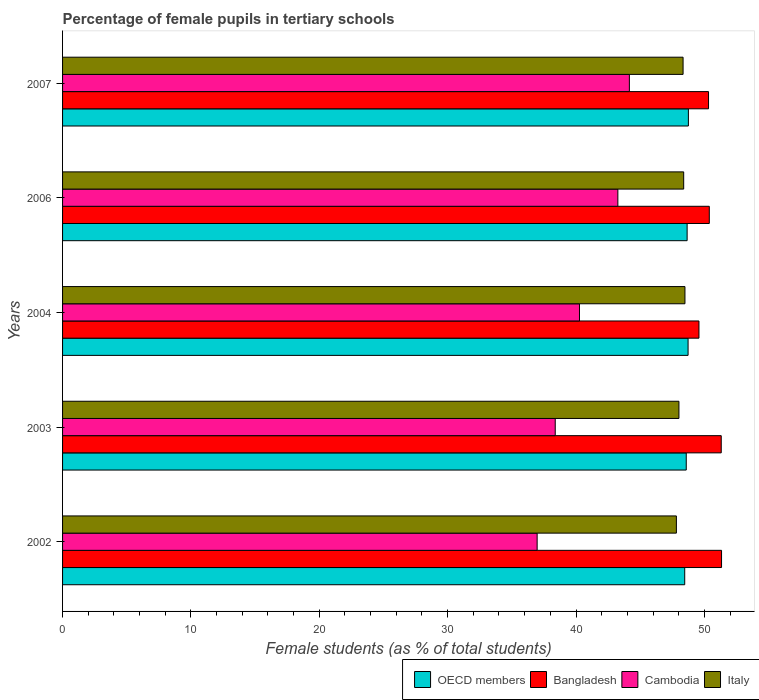How many groups of bars are there?
Your answer should be very brief. 5. Are the number of bars per tick equal to the number of legend labels?
Offer a terse response. Yes. Are the number of bars on each tick of the Y-axis equal?
Provide a short and direct response. Yes. How many bars are there on the 2nd tick from the bottom?
Give a very brief answer. 4. What is the label of the 3rd group of bars from the top?
Make the answer very short. 2004. What is the percentage of female pupils in tertiary schools in Italy in 2002?
Provide a short and direct response. 47.82. Across all years, what is the maximum percentage of female pupils in tertiary schools in Bangladesh?
Make the answer very short. 51.34. Across all years, what is the minimum percentage of female pupils in tertiary schools in Cambodia?
Give a very brief answer. 36.97. In which year was the percentage of female pupils in tertiary schools in Cambodia maximum?
Ensure brevity in your answer.  2007. In which year was the percentage of female pupils in tertiary schools in Cambodia minimum?
Your answer should be very brief. 2002. What is the total percentage of female pupils in tertiary schools in OECD members in the graph?
Offer a terse response. 243.2. What is the difference between the percentage of female pupils in tertiary schools in Italy in 2002 and that in 2007?
Offer a terse response. -0.52. What is the difference between the percentage of female pupils in tertiary schools in Italy in 2004 and the percentage of female pupils in tertiary schools in Bangladesh in 2003?
Ensure brevity in your answer.  -2.83. What is the average percentage of female pupils in tertiary schools in Bangladesh per year?
Offer a terse response. 50.59. In the year 2007, what is the difference between the percentage of female pupils in tertiary schools in Bangladesh and percentage of female pupils in tertiary schools in Italy?
Offer a terse response. 1.98. In how many years, is the percentage of female pupils in tertiary schools in OECD members greater than 34 %?
Your answer should be compact. 5. What is the ratio of the percentage of female pupils in tertiary schools in Italy in 2002 to that in 2007?
Provide a short and direct response. 0.99. What is the difference between the highest and the second highest percentage of female pupils in tertiary schools in Bangladesh?
Offer a very short reply. 0.02. What is the difference between the highest and the lowest percentage of female pupils in tertiary schools in OECD members?
Provide a succinct answer. 0.29. In how many years, is the percentage of female pupils in tertiary schools in Bangladesh greater than the average percentage of female pupils in tertiary schools in Bangladesh taken over all years?
Make the answer very short. 2. Is the sum of the percentage of female pupils in tertiary schools in Cambodia in 2006 and 2007 greater than the maximum percentage of female pupils in tertiary schools in Italy across all years?
Provide a short and direct response. Yes. What does the 3rd bar from the top in 2002 represents?
Provide a succinct answer. Bangladesh. Is it the case that in every year, the sum of the percentage of female pupils in tertiary schools in OECD members and percentage of female pupils in tertiary schools in Cambodia is greater than the percentage of female pupils in tertiary schools in Italy?
Make the answer very short. Yes. Does the graph contain any zero values?
Your answer should be compact. No. Does the graph contain grids?
Your answer should be very brief. No. How many legend labels are there?
Your response must be concise. 4. How are the legend labels stacked?
Your answer should be compact. Horizontal. What is the title of the graph?
Your response must be concise. Percentage of female pupils in tertiary schools. What is the label or title of the X-axis?
Your answer should be compact. Female students (as % of total students). What is the Female students (as % of total students) of OECD members in 2002?
Offer a terse response. 48.47. What is the Female students (as % of total students) in Bangladesh in 2002?
Offer a terse response. 51.34. What is the Female students (as % of total students) in Cambodia in 2002?
Provide a succinct answer. 36.97. What is the Female students (as % of total students) in Italy in 2002?
Keep it short and to the point. 47.82. What is the Female students (as % of total students) of OECD members in 2003?
Your answer should be very brief. 48.59. What is the Female students (as % of total students) of Bangladesh in 2003?
Your answer should be compact. 51.31. What is the Female students (as % of total students) in Cambodia in 2003?
Your answer should be compact. 38.38. What is the Female students (as % of total students) in Italy in 2003?
Your answer should be very brief. 48.02. What is the Female students (as % of total students) in OECD members in 2004?
Offer a terse response. 48.73. What is the Female students (as % of total students) in Bangladesh in 2004?
Offer a terse response. 49.58. What is the Female students (as % of total students) in Cambodia in 2004?
Offer a very short reply. 40.27. What is the Female students (as % of total students) of Italy in 2004?
Provide a succinct answer. 48.49. What is the Female students (as % of total students) of OECD members in 2006?
Keep it short and to the point. 48.66. What is the Female students (as % of total students) in Bangladesh in 2006?
Your answer should be very brief. 50.38. What is the Female students (as % of total students) in Cambodia in 2006?
Give a very brief answer. 43.26. What is the Female students (as % of total students) of Italy in 2006?
Your answer should be compact. 48.39. What is the Female students (as % of total students) of OECD members in 2007?
Your response must be concise. 48.76. What is the Female students (as % of total students) of Bangladesh in 2007?
Provide a succinct answer. 50.32. What is the Female students (as % of total students) of Cambodia in 2007?
Your response must be concise. 44.16. What is the Female students (as % of total students) of Italy in 2007?
Your answer should be compact. 48.34. Across all years, what is the maximum Female students (as % of total students) of OECD members?
Your response must be concise. 48.76. Across all years, what is the maximum Female students (as % of total students) of Bangladesh?
Your response must be concise. 51.34. Across all years, what is the maximum Female students (as % of total students) in Cambodia?
Offer a terse response. 44.16. Across all years, what is the maximum Female students (as % of total students) in Italy?
Your answer should be very brief. 48.49. Across all years, what is the minimum Female students (as % of total students) in OECD members?
Provide a short and direct response. 48.47. Across all years, what is the minimum Female students (as % of total students) in Bangladesh?
Make the answer very short. 49.58. Across all years, what is the minimum Female students (as % of total students) of Cambodia?
Your response must be concise. 36.97. Across all years, what is the minimum Female students (as % of total students) in Italy?
Give a very brief answer. 47.82. What is the total Female students (as % of total students) of OECD members in the graph?
Give a very brief answer. 243.2. What is the total Female students (as % of total students) in Bangladesh in the graph?
Make the answer very short. 252.94. What is the total Female students (as % of total students) of Cambodia in the graph?
Keep it short and to the point. 203.05. What is the total Female students (as % of total students) in Italy in the graph?
Offer a terse response. 241.06. What is the difference between the Female students (as % of total students) in OECD members in 2002 and that in 2003?
Your response must be concise. -0.12. What is the difference between the Female students (as % of total students) in Bangladesh in 2002 and that in 2003?
Your answer should be compact. 0.02. What is the difference between the Female students (as % of total students) in Cambodia in 2002 and that in 2003?
Offer a very short reply. -1.41. What is the difference between the Female students (as % of total students) of Italy in 2002 and that in 2003?
Provide a succinct answer. -0.2. What is the difference between the Female students (as % of total students) in OECD members in 2002 and that in 2004?
Your answer should be compact. -0.26. What is the difference between the Female students (as % of total students) in Bangladesh in 2002 and that in 2004?
Offer a terse response. 1.76. What is the difference between the Female students (as % of total students) in Cambodia in 2002 and that in 2004?
Keep it short and to the point. -3.3. What is the difference between the Female students (as % of total students) of Italy in 2002 and that in 2004?
Provide a short and direct response. -0.67. What is the difference between the Female students (as % of total students) of OECD members in 2002 and that in 2006?
Give a very brief answer. -0.19. What is the difference between the Female students (as % of total students) in Bangladesh in 2002 and that in 2006?
Offer a very short reply. 0.95. What is the difference between the Female students (as % of total students) of Cambodia in 2002 and that in 2006?
Ensure brevity in your answer.  -6.29. What is the difference between the Female students (as % of total students) in Italy in 2002 and that in 2006?
Provide a succinct answer. -0.57. What is the difference between the Female students (as % of total students) of OECD members in 2002 and that in 2007?
Offer a terse response. -0.29. What is the difference between the Female students (as % of total students) of Cambodia in 2002 and that in 2007?
Make the answer very short. -7.19. What is the difference between the Female students (as % of total students) in Italy in 2002 and that in 2007?
Your answer should be compact. -0.52. What is the difference between the Female students (as % of total students) of OECD members in 2003 and that in 2004?
Provide a succinct answer. -0.14. What is the difference between the Female students (as % of total students) in Bangladesh in 2003 and that in 2004?
Your response must be concise. 1.74. What is the difference between the Female students (as % of total students) in Cambodia in 2003 and that in 2004?
Your answer should be compact. -1.89. What is the difference between the Female students (as % of total students) of Italy in 2003 and that in 2004?
Provide a short and direct response. -0.47. What is the difference between the Female students (as % of total students) in OECD members in 2003 and that in 2006?
Make the answer very short. -0.07. What is the difference between the Female students (as % of total students) in Bangladesh in 2003 and that in 2006?
Your answer should be very brief. 0.93. What is the difference between the Female students (as % of total students) in Cambodia in 2003 and that in 2006?
Give a very brief answer. -4.88. What is the difference between the Female students (as % of total students) in Italy in 2003 and that in 2006?
Your answer should be compact. -0.37. What is the difference between the Female students (as % of total students) of OECD members in 2003 and that in 2007?
Give a very brief answer. -0.17. What is the difference between the Female students (as % of total students) in Cambodia in 2003 and that in 2007?
Your answer should be very brief. -5.78. What is the difference between the Female students (as % of total students) of Italy in 2003 and that in 2007?
Your answer should be very brief. -0.32. What is the difference between the Female students (as % of total students) in OECD members in 2004 and that in 2006?
Provide a succinct answer. 0.07. What is the difference between the Female students (as % of total students) in Bangladesh in 2004 and that in 2006?
Offer a very short reply. -0.81. What is the difference between the Female students (as % of total students) in Cambodia in 2004 and that in 2006?
Make the answer very short. -2.99. What is the difference between the Female students (as % of total students) in Italy in 2004 and that in 2006?
Keep it short and to the point. 0.1. What is the difference between the Female students (as % of total students) of OECD members in 2004 and that in 2007?
Make the answer very short. -0.02. What is the difference between the Female students (as % of total students) of Bangladesh in 2004 and that in 2007?
Your response must be concise. -0.75. What is the difference between the Female students (as % of total students) in Cambodia in 2004 and that in 2007?
Provide a succinct answer. -3.89. What is the difference between the Female students (as % of total students) of Italy in 2004 and that in 2007?
Your answer should be very brief. 0.15. What is the difference between the Female students (as % of total students) of OECD members in 2006 and that in 2007?
Provide a succinct answer. -0.1. What is the difference between the Female students (as % of total students) in Bangladesh in 2006 and that in 2007?
Your answer should be very brief. 0.06. What is the difference between the Female students (as % of total students) of Cambodia in 2006 and that in 2007?
Offer a terse response. -0.9. What is the difference between the Female students (as % of total students) in Italy in 2006 and that in 2007?
Provide a short and direct response. 0.05. What is the difference between the Female students (as % of total students) of OECD members in 2002 and the Female students (as % of total students) of Bangladesh in 2003?
Your answer should be compact. -2.85. What is the difference between the Female students (as % of total students) of OECD members in 2002 and the Female students (as % of total students) of Cambodia in 2003?
Your response must be concise. 10.09. What is the difference between the Female students (as % of total students) in OECD members in 2002 and the Female students (as % of total students) in Italy in 2003?
Your answer should be compact. 0.45. What is the difference between the Female students (as % of total students) in Bangladesh in 2002 and the Female students (as % of total students) in Cambodia in 2003?
Give a very brief answer. 12.96. What is the difference between the Female students (as % of total students) of Bangladesh in 2002 and the Female students (as % of total students) of Italy in 2003?
Keep it short and to the point. 3.32. What is the difference between the Female students (as % of total students) of Cambodia in 2002 and the Female students (as % of total students) of Italy in 2003?
Provide a short and direct response. -11.05. What is the difference between the Female students (as % of total students) in OECD members in 2002 and the Female students (as % of total students) in Bangladesh in 2004?
Offer a very short reply. -1.11. What is the difference between the Female students (as % of total students) of OECD members in 2002 and the Female students (as % of total students) of Cambodia in 2004?
Provide a short and direct response. 8.2. What is the difference between the Female students (as % of total students) of OECD members in 2002 and the Female students (as % of total students) of Italy in 2004?
Make the answer very short. -0.02. What is the difference between the Female students (as % of total students) in Bangladesh in 2002 and the Female students (as % of total students) in Cambodia in 2004?
Give a very brief answer. 11.07. What is the difference between the Female students (as % of total students) in Bangladesh in 2002 and the Female students (as % of total students) in Italy in 2004?
Keep it short and to the point. 2.85. What is the difference between the Female students (as % of total students) in Cambodia in 2002 and the Female students (as % of total students) in Italy in 2004?
Offer a very short reply. -11.52. What is the difference between the Female students (as % of total students) in OECD members in 2002 and the Female students (as % of total students) in Bangladesh in 2006?
Your answer should be very brief. -1.92. What is the difference between the Female students (as % of total students) of OECD members in 2002 and the Female students (as % of total students) of Cambodia in 2006?
Your answer should be very brief. 5.21. What is the difference between the Female students (as % of total students) of OECD members in 2002 and the Female students (as % of total students) of Italy in 2006?
Offer a terse response. 0.08. What is the difference between the Female students (as % of total students) in Bangladesh in 2002 and the Female students (as % of total students) in Cambodia in 2006?
Your answer should be compact. 8.08. What is the difference between the Female students (as % of total students) of Bangladesh in 2002 and the Female students (as % of total students) of Italy in 2006?
Provide a succinct answer. 2.95. What is the difference between the Female students (as % of total students) in Cambodia in 2002 and the Female students (as % of total students) in Italy in 2006?
Your answer should be very brief. -11.42. What is the difference between the Female students (as % of total students) in OECD members in 2002 and the Female students (as % of total students) in Bangladesh in 2007?
Make the answer very short. -1.85. What is the difference between the Female students (as % of total students) in OECD members in 2002 and the Female students (as % of total students) in Cambodia in 2007?
Keep it short and to the point. 4.31. What is the difference between the Female students (as % of total students) in OECD members in 2002 and the Female students (as % of total students) in Italy in 2007?
Provide a short and direct response. 0.13. What is the difference between the Female students (as % of total students) in Bangladesh in 2002 and the Female students (as % of total students) in Cambodia in 2007?
Offer a terse response. 7.18. What is the difference between the Female students (as % of total students) in Bangladesh in 2002 and the Female students (as % of total students) in Italy in 2007?
Your answer should be compact. 3. What is the difference between the Female students (as % of total students) in Cambodia in 2002 and the Female students (as % of total students) in Italy in 2007?
Your answer should be compact. -11.37. What is the difference between the Female students (as % of total students) in OECD members in 2003 and the Female students (as % of total students) in Bangladesh in 2004?
Your answer should be compact. -0.99. What is the difference between the Female students (as % of total students) of OECD members in 2003 and the Female students (as % of total students) of Cambodia in 2004?
Provide a succinct answer. 8.32. What is the difference between the Female students (as % of total students) of OECD members in 2003 and the Female students (as % of total students) of Italy in 2004?
Offer a very short reply. 0.1. What is the difference between the Female students (as % of total students) of Bangladesh in 2003 and the Female students (as % of total students) of Cambodia in 2004?
Provide a succinct answer. 11.04. What is the difference between the Female students (as % of total students) in Bangladesh in 2003 and the Female students (as % of total students) in Italy in 2004?
Offer a very short reply. 2.83. What is the difference between the Female students (as % of total students) in Cambodia in 2003 and the Female students (as % of total students) in Italy in 2004?
Your response must be concise. -10.11. What is the difference between the Female students (as % of total students) in OECD members in 2003 and the Female students (as % of total students) in Bangladesh in 2006?
Keep it short and to the point. -1.8. What is the difference between the Female students (as % of total students) in OECD members in 2003 and the Female students (as % of total students) in Cambodia in 2006?
Offer a very short reply. 5.33. What is the difference between the Female students (as % of total students) in OECD members in 2003 and the Female students (as % of total students) in Italy in 2006?
Provide a short and direct response. 0.2. What is the difference between the Female students (as % of total students) in Bangladesh in 2003 and the Female students (as % of total students) in Cambodia in 2006?
Your answer should be very brief. 8.05. What is the difference between the Female students (as % of total students) of Bangladesh in 2003 and the Female students (as % of total students) of Italy in 2006?
Your response must be concise. 2.93. What is the difference between the Female students (as % of total students) of Cambodia in 2003 and the Female students (as % of total students) of Italy in 2006?
Your response must be concise. -10.01. What is the difference between the Female students (as % of total students) in OECD members in 2003 and the Female students (as % of total students) in Bangladesh in 2007?
Your answer should be very brief. -1.74. What is the difference between the Female students (as % of total students) of OECD members in 2003 and the Female students (as % of total students) of Cambodia in 2007?
Make the answer very short. 4.43. What is the difference between the Female students (as % of total students) of OECD members in 2003 and the Female students (as % of total students) of Italy in 2007?
Provide a short and direct response. 0.25. What is the difference between the Female students (as % of total students) in Bangladesh in 2003 and the Female students (as % of total students) in Cambodia in 2007?
Provide a succinct answer. 7.16. What is the difference between the Female students (as % of total students) in Bangladesh in 2003 and the Female students (as % of total students) in Italy in 2007?
Your response must be concise. 2.97. What is the difference between the Female students (as % of total students) in Cambodia in 2003 and the Female students (as % of total students) in Italy in 2007?
Keep it short and to the point. -9.96. What is the difference between the Female students (as % of total students) in OECD members in 2004 and the Female students (as % of total students) in Bangladesh in 2006?
Offer a very short reply. -1.65. What is the difference between the Female students (as % of total students) of OECD members in 2004 and the Female students (as % of total students) of Cambodia in 2006?
Provide a short and direct response. 5.47. What is the difference between the Female students (as % of total students) in OECD members in 2004 and the Female students (as % of total students) in Italy in 2006?
Make the answer very short. 0.34. What is the difference between the Female students (as % of total students) of Bangladesh in 2004 and the Female students (as % of total students) of Cambodia in 2006?
Provide a succinct answer. 6.32. What is the difference between the Female students (as % of total students) of Bangladesh in 2004 and the Female students (as % of total students) of Italy in 2006?
Give a very brief answer. 1.19. What is the difference between the Female students (as % of total students) of Cambodia in 2004 and the Female students (as % of total students) of Italy in 2006?
Your answer should be compact. -8.12. What is the difference between the Female students (as % of total students) of OECD members in 2004 and the Female students (as % of total students) of Bangladesh in 2007?
Provide a short and direct response. -1.59. What is the difference between the Female students (as % of total students) of OECD members in 2004 and the Female students (as % of total students) of Cambodia in 2007?
Ensure brevity in your answer.  4.57. What is the difference between the Female students (as % of total students) of OECD members in 2004 and the Female students (as % of total students) of Italy in 2007?
Ensure brevity in your answer.  0.39. What is the difference between the Female students (as % of total students) in Bangladesh in 2004 and the Female students (as % of total students) in Cambodia in 2007?
Provide a succinct answer. 5.42. What is the difference between the Female students (as % of total students) of Bangladesh in 2004 and the Female students (as % of total students) of Italy in 2007?
Give a very brief answer. 1.24. What is the difference between the Female students (as % of total students) in Cambodia in 2004 and the Female students (as % of total students) in Italy in 2007?
Your response must be concise. -8.07. What is the difference between the Female students (as % of total students) of OECD members in 2006 and the Female students (as % of total students) of Bangladesh in 2007?
Your response must be concise. -1.67. What is the difference between the Female students (as % of total students) of OECD members in 2006 and the Female students (as % of total students) of Cambodia in 2007?
Keep it short and to the point. 4.5. What is the difference between the Female students (as % of total students) in OECD members in 2006 and the Female students (as % of total students) in Italy in 2007?
Offer a terse response. 0.31. What is the difference between the Female students (as % of total students) of Bangladesh in 2006 and the Female students (as % of total students) of Cambodia in 2007?
Ensure brevity in your answer.  6.23. What is the difference between the Female students (as % of total students) in Bangladesh in 2006 and the Female students (as % of total students) in Italy in 2007?
Your response must be concise. 2.04. What is the difference between the Female students (as % of total students) in Cambodia in 2006 and the Female students (as % of total students) in Italy in 2007?
Provide a short and direct response. -5.08. What is the average Female students (as % of total students) in OECD members per year?
Your answer should be very brief. 48.64. What is the average Female students (as % of total students) of Bangladesh per year?
Offer a terse response. 50.59. What is the average Female students (as % of total students) of Cambodia per year?
Your answer should be very brief. 40.61. What is the average Female students (as % of total students) of Italy per year?
Give a very brief answer. 48.21. In the year 2002, what is the difference between the Female students (as % of total students) of OECD members and Female students (as % of total students) of Bangladesh?
Offer a very short reply. -2.87. In the year 2002, what is the difference between the Female students (as % of total students) in OECD members and Female students (as % of total students) in Cambodia?
Keep it short and to the point. 11.5. In the year 2002, what is the difference between the Female students (as % of total students) of OECD members and Female students (as % of total students) of Italy?
Offer a very short reply. 0.65. In the year 2002, what is the difference between the Female students (as % of total students) in Bangladesh and Female students (as % of total students) in Cambodia?
Ensure brevity in your answer.  14.37. In the year 2002, what is the difference between the Female students (as % of total students) of Bangladesh and Female students (as % of total students) of Italy?
Your answer should be very brief. 3.52. In the year 2002, what is the difference between the Female students (as % of total students) in Cambodia and Female students (as % of total students) in Italy?
Ensure brevity in your answer.  -10.85. In the year 2003, what is the difference between the Female students (as % of total students) in OECD members and Female students (as % of total students) in Bangladesh?
Keep it short and to the point. -2.73. In the year 2003, what is the difference between the Female students (as % of total students) in OECD members and Female students (as % of total students) in Cambodia?
Provide a short and direct response. 10.21. In the year 2003, what is the difference between the Female students (as % of total students) of OECD members and Female students (as % of total students) of Italy?
Give a very brief answer. 0.57. In the year 2003, what is the difference between the Female students (as % of total students) in Bangladesh and Female students (as % of total students) in Cambodia?
Provide a succinct answer. 12.93. In the year 2003, what is the difference between the Female students (as % of total students) in Bangladesh and Female students (as % of total students) in Italy?
Ensure brevity in your answer.  3.3. In the year 2003, what is the difference between the Female students (as % of total students) in Cambodia and Female students (as % of total students) in Italy?
Offer a terse response. -9.64. In the year 2004, what is the difference between the Female students (as % of total students) of OECD members and Female students (as % of total students) of Bangladesh?
Give a very brief answer. -0.85. In the year 2004, what is the difference between the Female students (as % of total students) of OECD members and Female students (as % of total students) of Cambodia?
Keep it short and to the point. 8.46. In the year 2004, what is the difference between the Female students (as % of total students) in OECD members and Female students (as % of total students) in Italy?
Your answer should be compact. 0.24. In the year 2004, what is the difference between the Female students (as % of total students) in Bangladesh and Female students (as % of total students) in Cambodia?
Your answer should be very brief. 9.31. In the year 2004, what is the difference between the Female students (as % of total students) of Bangladesh and Female students (as % of total students) of Italy?
Provide a succinct answer. 1.09. In the year 2004, what is the difference between the Female students (as % of total students) of Cambodia and Female students (as % of total students) of Italy?
Your answer should be compact. -8.22. In the year 2006, what is the difference between the Female students (as % of total students) of OECD members and Female students (as % of total students) of Bangladesh?
Make the answer very short. -1.73. In the year 2006, what is the difference between the Female students (as % of total students) of OECD members and Female students (as % of total students) of Cambodia?
Offer a very short reply. 5.4. In the year 2006, what is the difference between the Female students (as % of total students) in OECD members and Female students (as % of total students) in Italy?
Provide a short and direct response. 0.27. In the year 2006, what is the difference between the Female students (as % of total students) of Bangladesh and Female students (as % of total students) of Cambodia?
Your response must be concise. 7.12. In the year 2006, what is the difference between the Female students (as % of total students) of Bangladesh and Female students (as % of total students) of Italy?
Keep it short and to the point. 2. In the year 2006, what is the difference between the Female students (as % of total students) in Cambodia and Female students (as % of total students) in Italy?
Provide a short and direct response. -5.13. In the year 2007, what is the difference between the Female students (as % of total students) of OECD members and Female students (as % of total students) of Bangladesh?
Ensure brevity in your answer.  -1.57. In the year 2007, what is the difference between the Female students (as % of total students) in OECD members and Female students (as % of total students) in Cambodia?
Make the answer very short. 4.6. In the year 2007, what is the difference between the Female students (as % of total students) in OECD members and Female students (as % of total students) in Italy?
Make the answer very short. 0.41. In the year 2007, what is the difference between the Female students (as % of total students) in Bangladesh and Female students (as % of total students) in Cambodia?
Give a very brief answer. 6.17. In the year 2007, what is the difference between the Female students (as % of total students) in Bangladesh and Female students (as % of total students) in Italy?
Provide a short and direct response. 1.98. In the year 2007, what is the difference between the Female students (as % of total students) of Cambodia and Female students (as % of total students) of Italy?
Offer a terse response. -4.18. What is the ratio of the Female students (as % of total students) of Bangladesh in 2002 to that in 2003?
Keep it short and to the point. 1. What is the ratio of the Female students (as % of total students) of Cambodia in 2002 to that in 2003?
Offer a terse response. 0.96. What is the ratio of the Female students (as % of total students) in Italy in 2002 to that in 2003?
Ensure brevity in your answer.  1. What is the ratio of the Female students (as % of total students) of Bangladesh in 2002 to that in 2004?
Provide a short and direct response. 1.04. What is the ratio of the Female students (as % of total students) in Cambodia in 2002 to that in 2004?
Give a very brief answer. 0.92. What is the ratio of the Female students (as % of total students) in Italy in 2002 to that in 2004?
Offer a very short reply. 0.99. What is the ratio of the Female students (as % of total students) of Bangladesh in 2002 to that in 2006?
Give a very brief answer. 1.02. What is the ratio of the Female students (as % of total students) in Cambodia in 2002 to that in 2006?
Provide a short and direct response. 0.85. What is the ratio of the Female students (as % of total students) in Italy in 2002 to that in 2006?
Your answer should be compact. 0.99. What is the ratio of the Female students (as % of total students) of Bangladesh in 2002 to that in 2007?
Offer a very short reply. 1.02. What is the ratio of the Female students (as % of total students) in Cambodia in 2002 to that in 2007?
Your answer should be very brief. 0.84. What is the ratio of the Female students (as % of total students) in Italy in 2002 to that in 2007?
Your answer should be compact. 0.99. What is the ratio of the Female students (as % of total students) of OECD members in 2003 to that in 2004?
Provide a short and direct response. 1. What is the ratio of the Female students (as % of total students) in Bangladesh in 2003 to that in 2004?
Offer a terse response. 1.03. What is the ratio of the Female students (as % of total students) of Cambodia in 2003 to that in 2004?
Keep it short and to the point. 0.95. What is the ratio of the Female students (as % of total students) in Italy in 2003 to that in 2004?
Provide a succinct answer. 0.99. What is the ratio of the Female students (as % of total students) in OECD members in 2003 to that in 2006?
Give a very brief answer. 1. What is the ratio of the Female students (as % of total students) in Bangladesh in 2003 to that in 2006?
Provide a succinct answer. 1.02. What is the ratio of the Female students (as % of total students) in Cambodia in 2003 to that in 2006?
Give a very brief answer. 0.89. What is the ratio of the Female students (as % of total students) in Italy in 2003 to that in 2006?
Your answer should be compact. 0.99. What is the ratio of the Female students (as % of total students) in OECD members in 2003 to that in 2007?
Provide a short and direct response. 1. What is the ratio of the Female students (as % of total students) of Bangladesh in 2003 to that in 2007?
Make the answer very short. 1.02. What is the ratio of the Female students (as % of total students) in Cambodia in 2003 to that in 2007?
Offer a terse response. 0.87. What is the ratio of the Female students (as % of total students) of OECD members in 2004 to that in 2006?
Provide a short and direct response. 1. What is the ratio of the Female students (as % of total students) in Bangladesh in 2004 to that in 2006?
Keep it short and to the point. 0.98. What is the ratio of the Female students (as % of total students) of Cambodia in 2004 to that in 2006?
Keep it short and to the point. 0.93. What is the ratio of the Female students (as % of total students) of OECD members in 2004 to that in 2007?
Your answer should be compact. 1. What is the ratio of the Female students (as % of total students) of Bangladesh in 2004 to that in 2007?
Keep it short and to the point. 0.99. What is the ratio of the Female students (as % of total students) in Cambodia in 2004 to that in 2007?
Offer a very short reply. 0.91. What is the ratio of the Female students (as % of total students) of Cambodia in 2006 to that in 2007?
Provide a succinct answer. 0.98. What is the ratio of the Female students (as % of total students) of Italy in 2006 to that in 2007?
Offer a very short reply. 1. What is the difference between the highest and the second highest Female students (as % of total students) in OECD members?
Your answer should be very brief. 0.02. What is the difference between the highest and the second highest Female students (as % of total students) of Bangladesh?
Offer a very short reply. 0.02. What is the difference between the highest and the second highest Female students (as % of total students) in Cambodia?
Ensure brevity in your answer.  0.9. What is the difference between the highest and the second highest Female students (as % of total students) in Italy?
Provide a succinct answer. 0.1. What is the difference between the highest and the lowest Female students (as % of total students) in OECD members?
Offer a very short reply. 0.29. What is the difference between the highest and the lowest Female students (as % of total students) in Bangladesh?
Your response must be concise. 1.76. What is the difference between the highest and the lowest Female students (as % of total students) of Cambodia?
Offer a terse response. 7.19. What is the difference between the highest and the lowest Female students (as % of total students) in Italy?
Give a very brief answer. 0.67. 